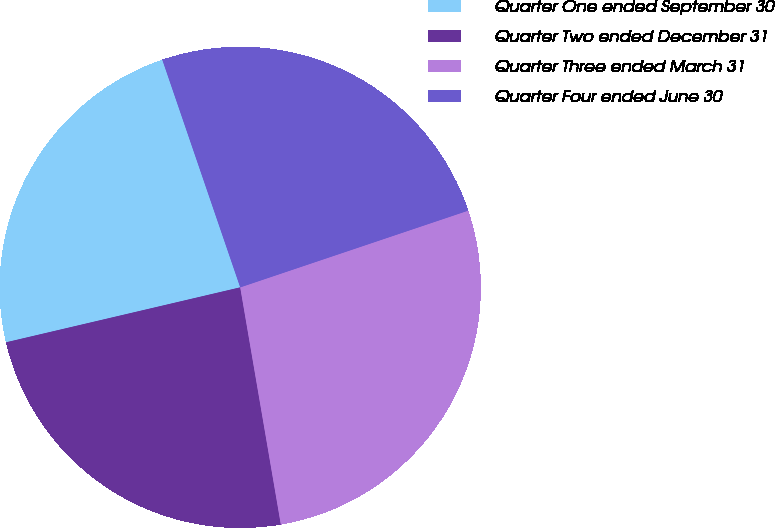<chart> <loc_0><loc_0><loc_500><loc_500><pie_chart><fcel>Quarter One ended September 30<fcel>Quarter Two ended December 31<fcel>Quarter Three ended March 31<fcel>Quarter Four ended June 30<nl><fcel>23.42%<fcel>24.03%<fcel>27.47%<fcel>25.08%<nl></chart> 